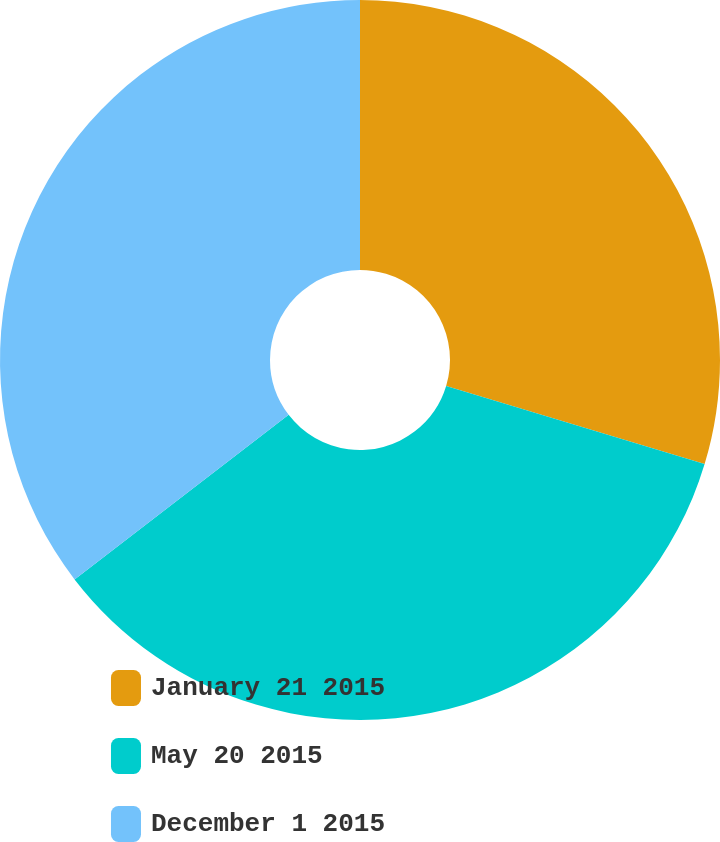Convert chart to OTSL. <chart><loc_0><loc_0><loc_500><loc_500><pie_chart><fcel>January 21 2015<fcel>May 20 2015<fcel>December 1 2015<nl><fcel>29.67%<fcel>34.9%<fcel>35.43%<nl></chart> 